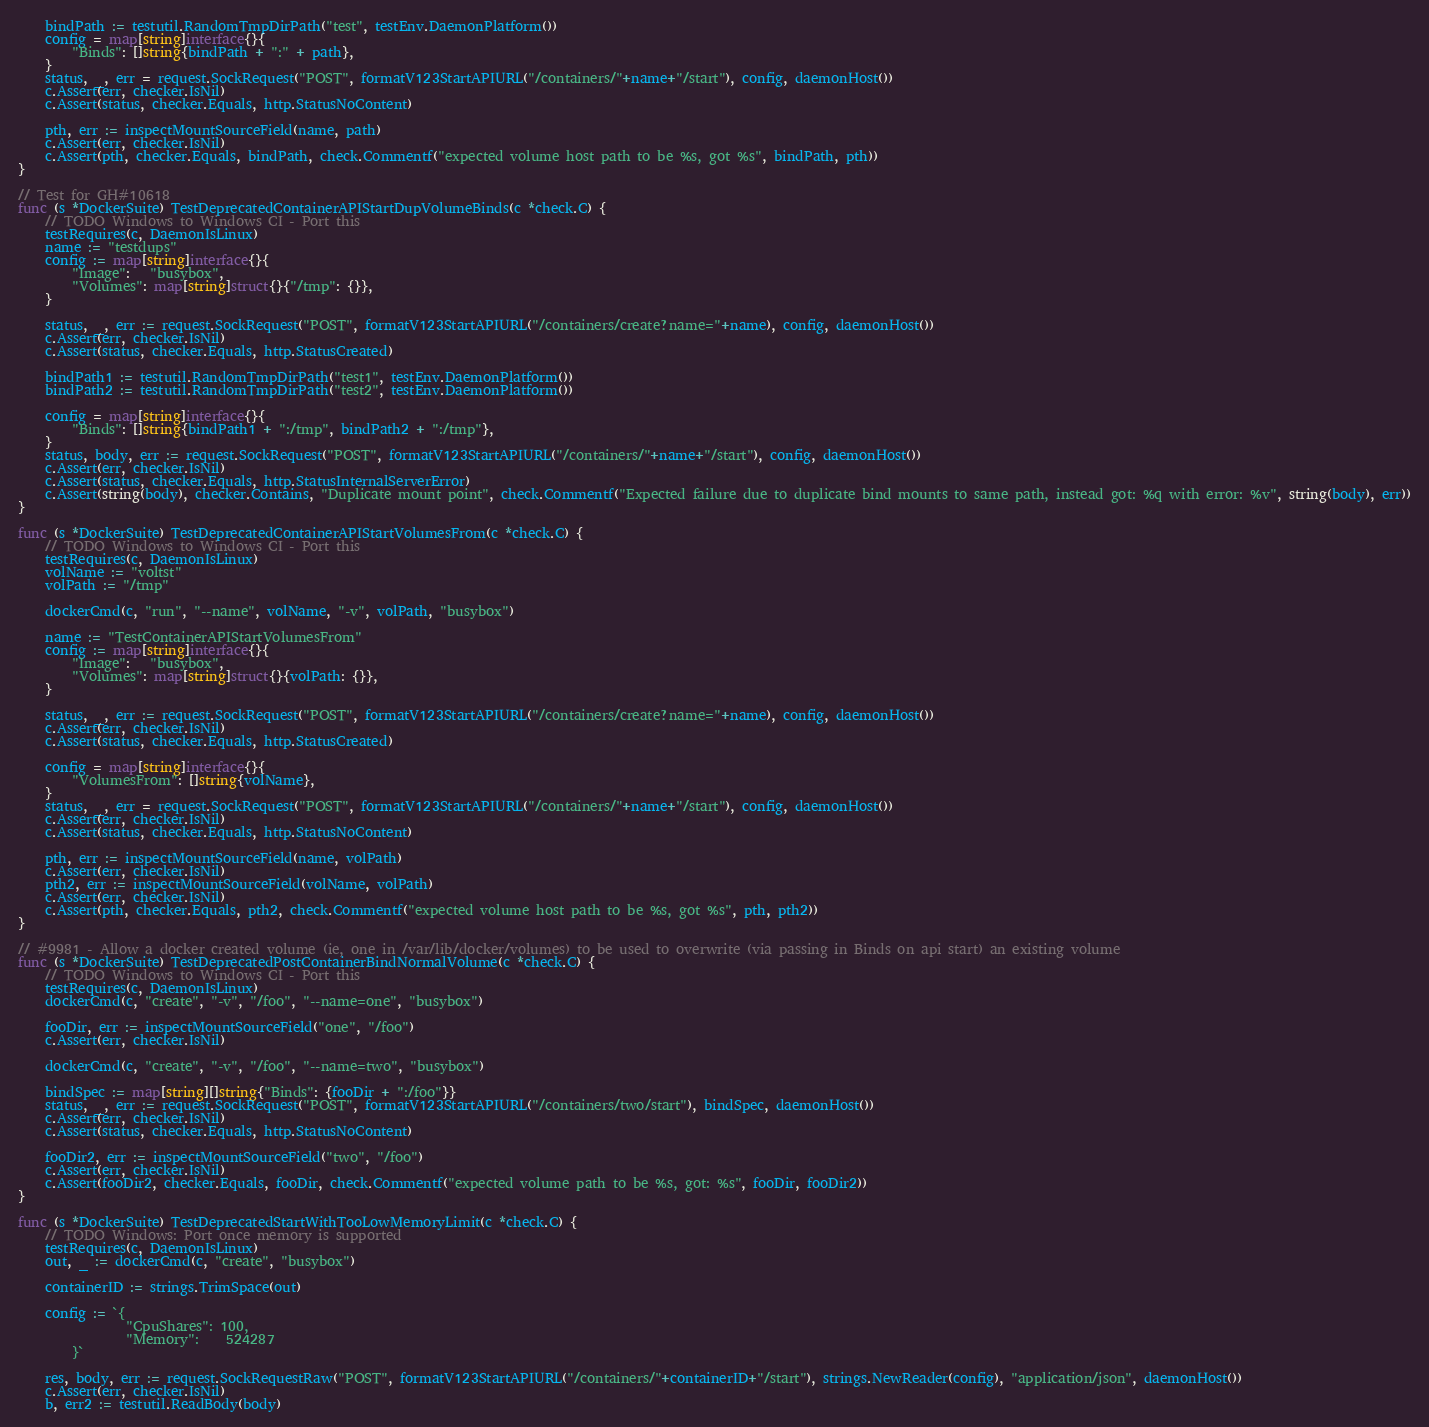<code> <loc_0><loc_0><loc_500><loc_500><_Go_>
	bindPath := testutil.RandomTmpDirPath("test", testEnv.DaemonPlatform())
	config = map[string]interface{}{
		"Binds": []string{bindPath + ":" + path},
	}
	status, _, err = request.SockRequest("POST", formatV123StartAPIURL("/containers/"+name+"/start"), config, daemonHost())
	c.Assert(err, checker.IsNil)
	c.Assert(status, checker.Equals, http.StatusNoContent)

	pth, err := inspectMountSourceField(name, path)
	c.Assert(err, checker.IsNil)
	c.Assert(pth, checker.Equals, bindPath, check.Commentf("expected volume host path to be %s, got %s", bindPath, pth))
}

// Test for GH#10618
func (s *DockerSuite) TestDeprecatedContainerAPIStartDupVolumeBinds(c *check.C) {
	// TODO Windows to Windows CI - Port this
	testRequires(c, DaemonIsLinux)
	name := "testdups"
	config := map[string]interface{}{
		"Image":   "busybox",
		"Volumes": map[string]struct{}{"/tmp": {}},
	}

	status, _, err := request.SockRequest("POST", formatV123StartAPIURL("/containers/create?name="+name), config, daemonHost())
	c.Assert(err, checker.IsNil)
	c.Assert(status, checker.Equals, http.StatusCreated)

	bindPath1 := testutil.RandomTmpDirPath("test1", testEnv.DaemonPlatform())
	bindPath2 := testutil.RandomTmpDirPath("test2", testEnv.DaemonPlatform())

	config = map[string]interface{}{
		"Binds": []string{bindPath1 + ":/tmp", bindPath2 + ":/tmp"},
	}
	status, body, err := request.SockRequest("POST", formatV123StartAPIURL("/containers/"+name+"/start"), config, daemonHost())
	c.Assert(err, checker.IsNil)
	c.Assert(status, checker.Equals, http.StatusInternalServerError)
	c.Assert(string(body), checker.Contains, "Duplicate mount point", check.Commentf("Expected failure due to duplicate bind mounts to same path, instead got: %q with error: %v", string(body), err))
}

func (s *DockerSuite) TestDeprecatedContainerAPIStartVolumesFrom(c *check.C) {
	// TODO Windows to Windows CI - Port this
	testRequires(c, DaemonIsLinux)
	volName := "voltst"
	volPath := "/tmp"

	dockerCmd(c, "run", "--name", volName, "-v", volPath, "busybox")

	name := "TestContainerAPIStartVolumesFrom"
	config := map[string]interface{}{
		"Image":   "busybox",
		"Volumes": map[string]struct{}{volPath: {}},
	}

	status, _, err := request.SockRequest("POST", formatV123StartAPIURL("/containers/create?name="+name), config, daemonHost())
	c.Assert(err, checker.IsNil)
	c.Assert(status, checker.Equals, http.StatusCreated)

	config = map[string]interface{}{
		"VolumesFrom": []string{volName},
	}
	status, _, err = request.SockRequest("POST", formatV123StartAPIURL("/containers/"+name+"/start"), config, daemonHost())
	c.Assert(err, checker.IsNil)
	c.Assert(status, checker.Equals, http.StatusNoContent)

	pth, err := inspectMountSourceField(name, volPath)
	c.Assert(err, checker.IsNil)
	pth2, err := inspectMountSourceField(volName, volPath)
	c.Assert(err, checker.IsNil)
	c.Assert(pth, checker.Equals, pth2, check.Commentf("expected volume host path to be %s, got %s", pth, pth2))
}

// #9981 - Allow a docker created volume (ie, one in /var/lib/docker/volumes) to be used to overwrite (via passing in Binds on api start) an existing volume
func (s *DockerSuite) TestDeprecatedPostContainerBindNormalVolume(c *check.C) {
	// TODO Windows to Windows CI - Port this
	testRequires(c, DaemonIsLinux)
	dockerCmd(c, "create", "-v", "/foo", "--name=one", "busybox")

	fooDir, err := inspectMountSourceField("one", "/foo")
	c.Assert(err, checker.IsNil)

	dockerCmd(c, "create", "-v", "/foo", "--name=two", "busybox")

	bindSpec := map[string][]string{"Binds": {fooDir + ":/foo"}}
	status, _, err := request.SockRequest("POST", formatV123StartAPIURL("/containers/two/start"), bindSpec, daemonHost())
	c.Assert(err, checker.IsNil)
	c.Assert(status, checker.Equals, http.StatusNoContent)

	fooDir2, err := inspectMountSourceField("two", "/foo")
	c.Assert(err, checker.IsNil)
	c.Assert(fooDir2, checker.Equals, fooDir, check.Commentf("expected volume path to be %s, got: %s", fooDir, fooDir2))
}

func (s *DockerSuite) TestDeprecatedStartWithTooLowMemoryLimit(c *check.C) {
	// TODO Windows: Port once memory is supported
	testRequires(c, DaemonIsLinux)
	out, _ := dockerCmd(c, "create", "busybox")

	containerID := strings.TrimSpace(out)

	config := `{
                "CpuShares": 100,
                "Memory":    524287
        }`

	res, body, err := request.SockRequestRaw("POST", formatV123StartAPIURL("/containers/"+containerID+"/start"), strings.NewReader(config), "application/json", daemonHost())
	c.Assert(err, checker.IsNil)
	b, err2 := testutil.ReadBody(body)</code> 